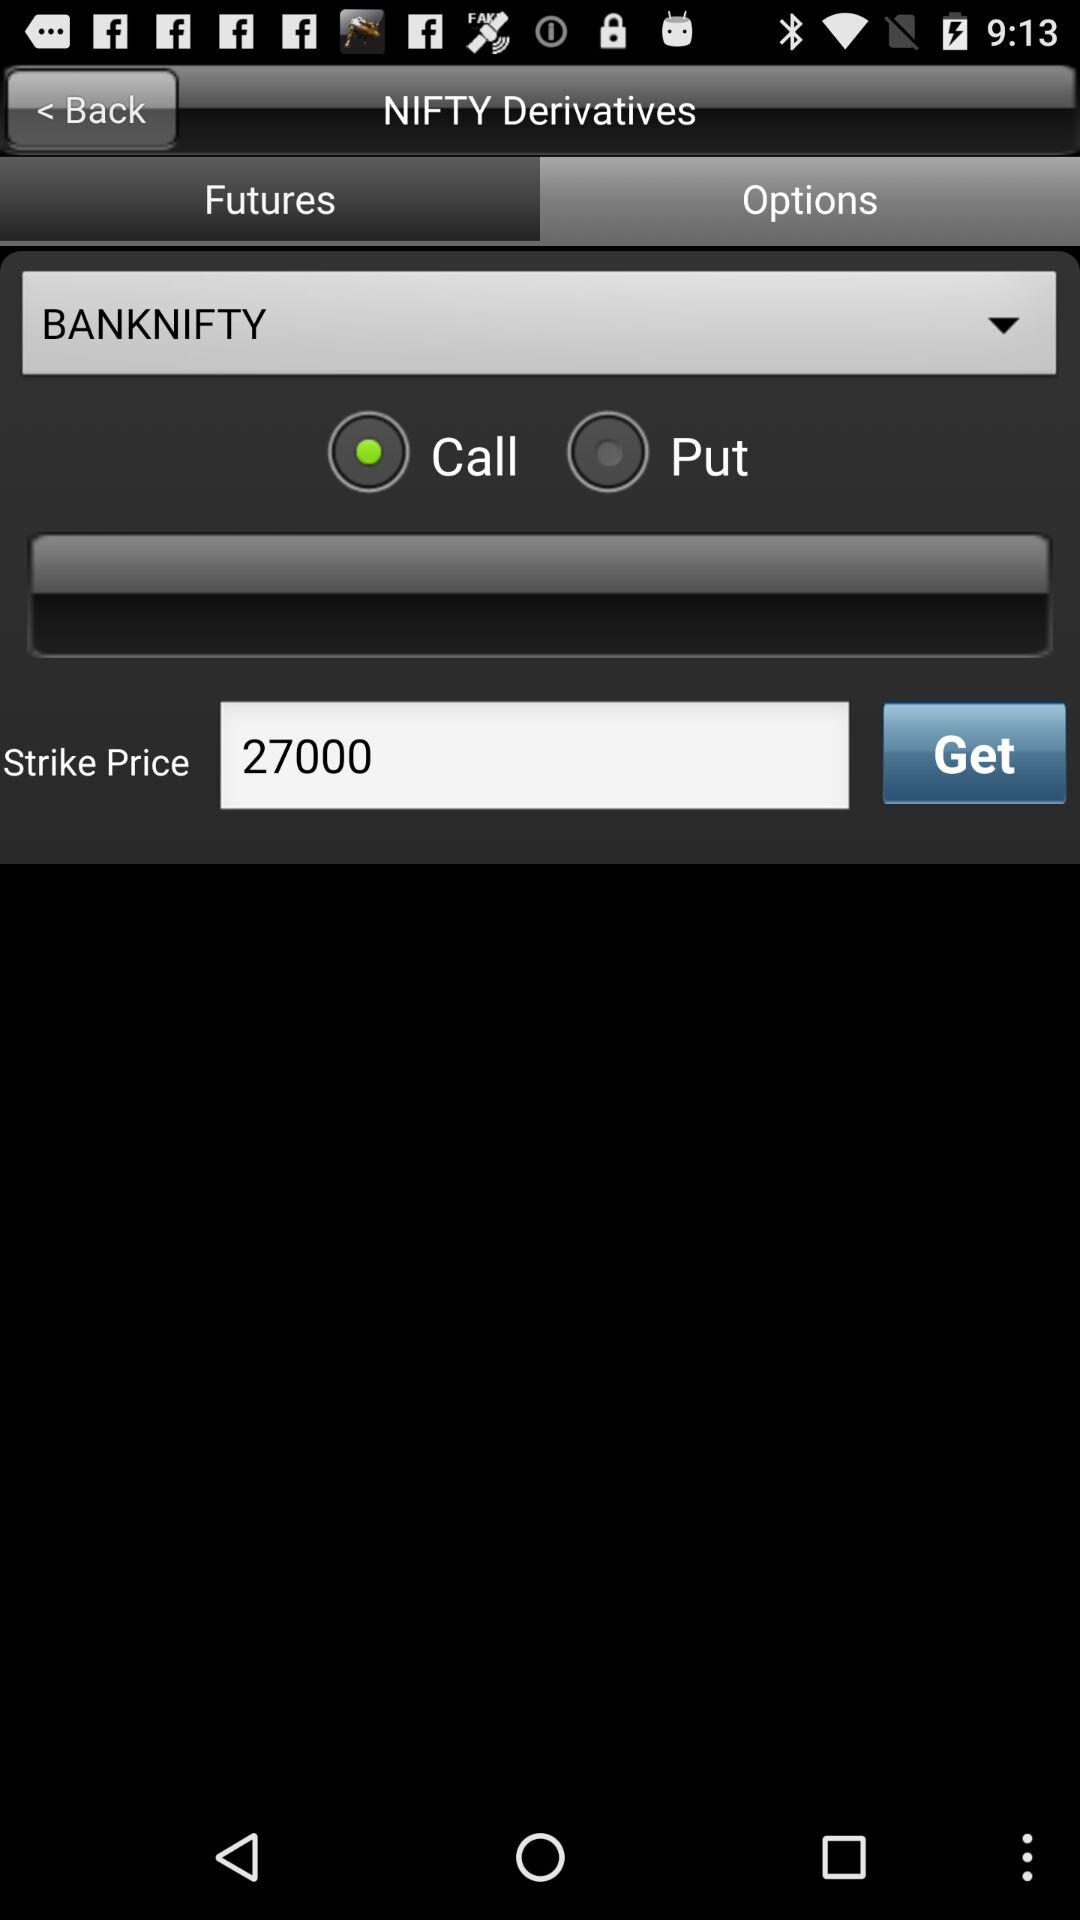What is the selected option in Banknifty? The selected option is "Call". 